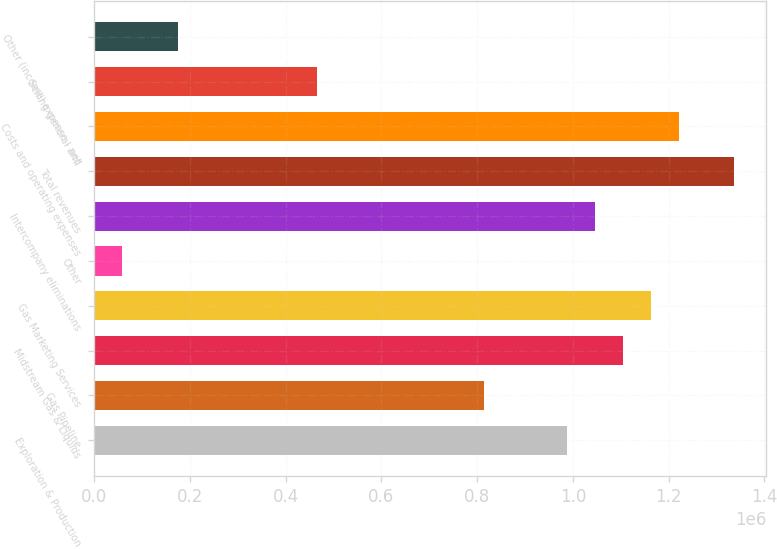Convert chart. <chart><loc_0><loc_0><loc_500><loc_500><bar_chart><fcel>Exploration & Production<fcel>Gas Pipeline<fcel>Midstream Gas & Liquids<fcel>Gas Marketing Services<fcel>Other<fcel>Intercompany eliminations<fcel>Total revenues<fcel>Costs and operating expenses<fcel>Selling general and<fcel>Other (income) expense - net<nl><fcel>988281<fcel>813878<fcel>1.10455e+06<fcel>1.16268e+06<fcel>58135.1<fcel>1.04641e+06<fcel>1.33709e+06<fcel>1.22082e+06<fcel>465074<fcel>174403<nl></chart> 